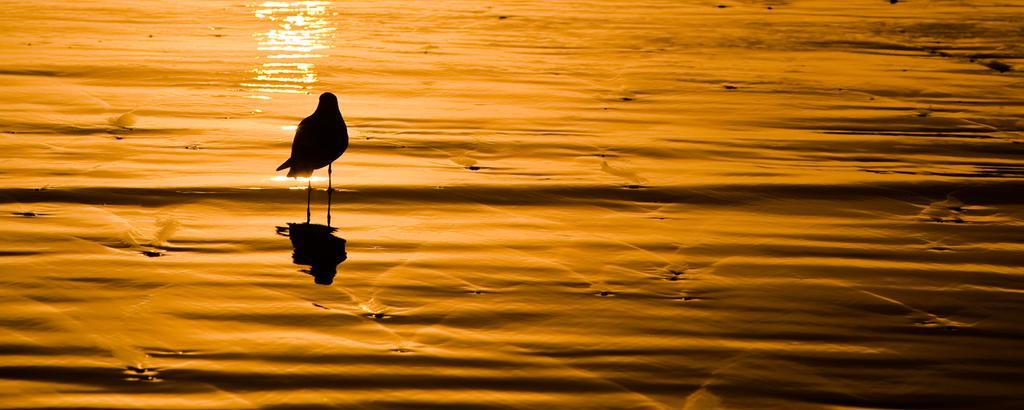Can you describe this image briefly? In this picture, we see a bird in black color is in the water. This picture might be clicked at the time of sunset. 